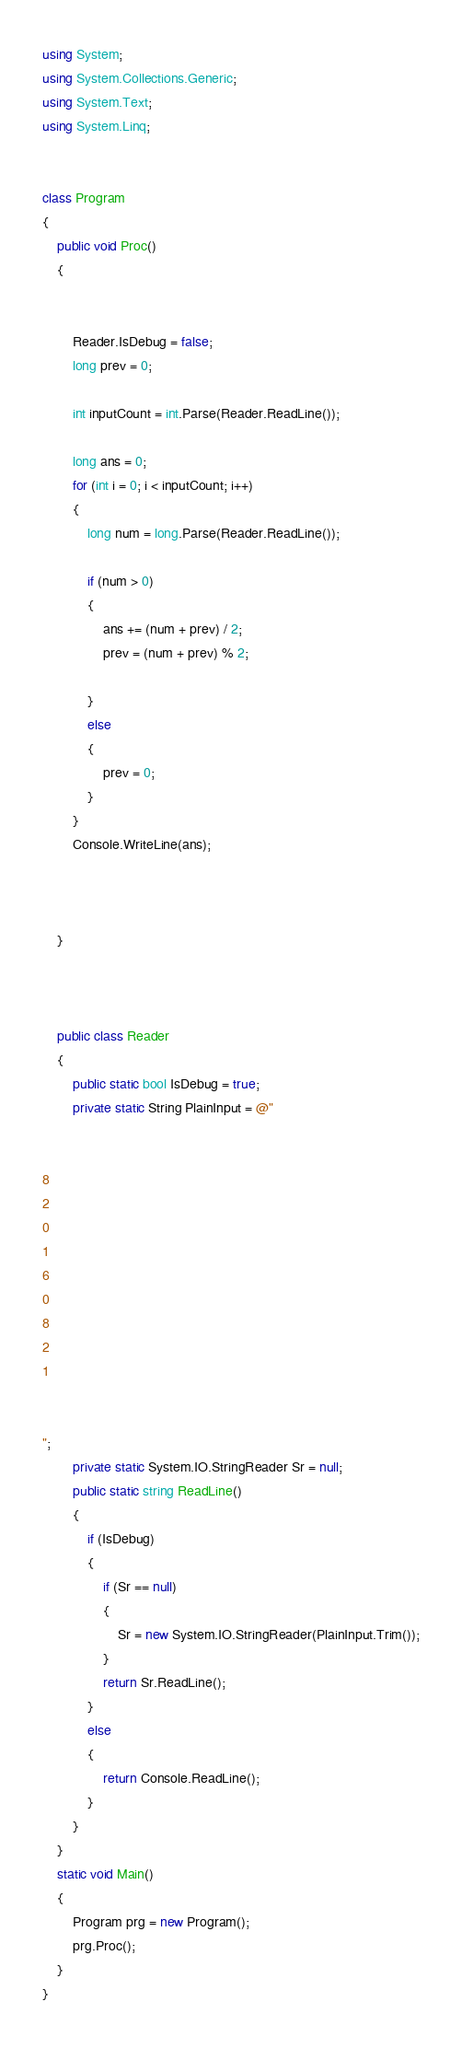Convert code to text. <code><loc_0><loc_0><loc_500><loc_500><_C#_>using System;
using System.Collections.Generic;
using System.Text;
using System.Linq;


class Program
{
    public void Proc()
    {


        Reader.IsDebug = false;
        long prev = 0;

        int inputCount = int.Parse(Reader.ReadLine());

        long ans = 0;
        for (int i = 0; i < inputCount; i++)
        {
            long num = long.Parse(Reader.ReadLine());

            if (num > 0)
            {
                ans += (num + prev) / 2;
                prev = (num + prev) % 2;

            }
            else
            {
                prev = 0;
            }
        }
        Console.WriteLine(ans);
 


    }



    public class Reader
    {
        public static bool IsDebug = true;
        private static String PlainInput = @"


8
2
0
1
6
0
8
2
1


";
        private static System.IO.StringReader Sr = null;
        public static string ReadLine()
        {
            if (IsDebug)
            {
                if (Sr == null)
                {
                    Sr = new System.IO.StringReader(PlainInput.Trim());
                }
                return Sr.ReadLine();
            }
            else
            {
                return Console.ReadLine();
            }
        }
    }
    static void Main()
    {
        Program prg = new Program();
        prg.Proc();
    }
}</code> 